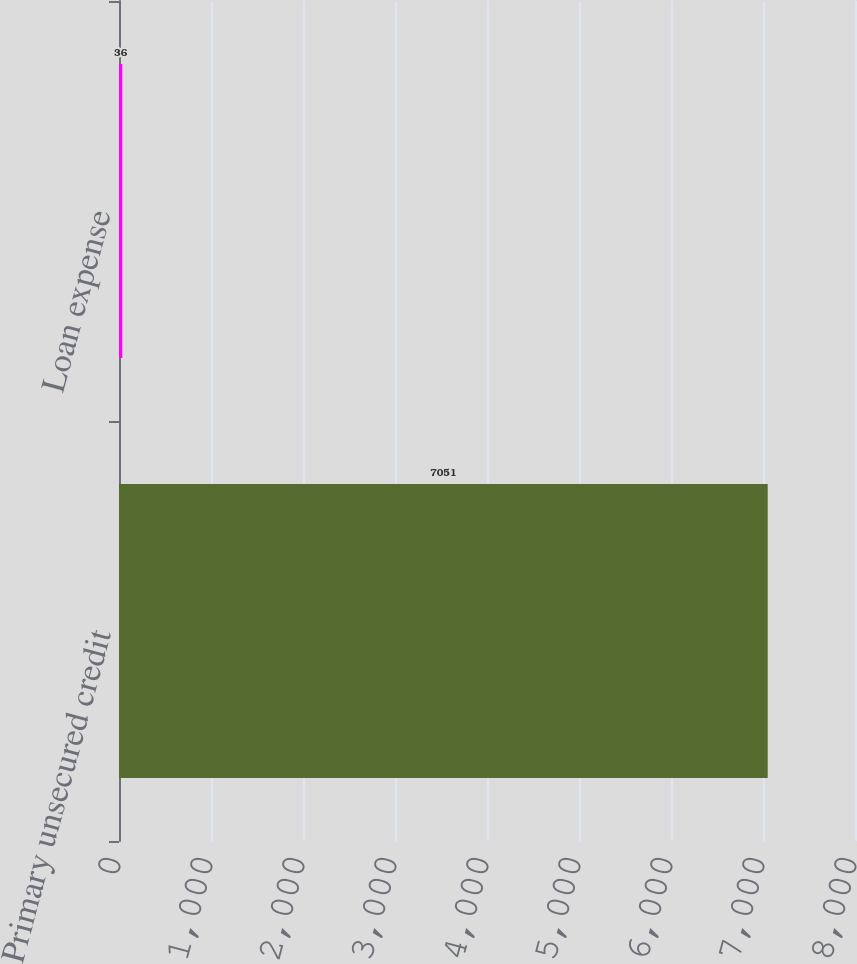Convert chart. <chart><loc_0><loc_0><loc_500><loc_500><bar_chart><fcel>Primary unsecured credit<fcel>Loan expense<nl><fcel>7051<fcel>36<nl></chart> 